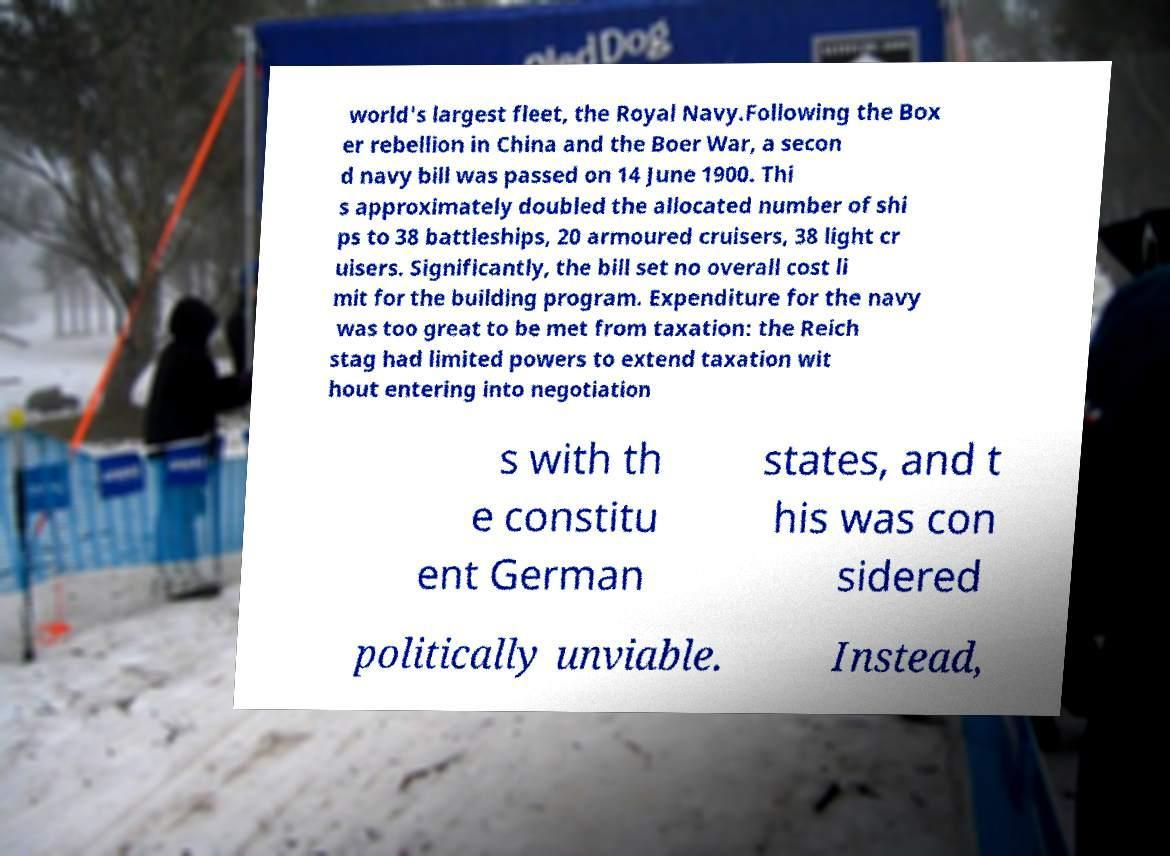Please read and relay the text visible in this image. What does it say? world's largest fleet, the Royal Navy.Following the Box er rebellion in China and the Boer War, a secon d navy bill was passed on 14 June 1900. Thi s approximately doubled the allocated number of shi ps to 38 battleships, 20 armoured cruisers, 38 light cr uisers. Significantly, the bill set no overall cost li mit for the building program. Expenditure for the navy was too great to be met from taxation: the Reich stag had limited powers to extend taxation wit hout entering into negotiation s with th e constitu ent German states, and t his was con sidered politically unviable. Instead, 